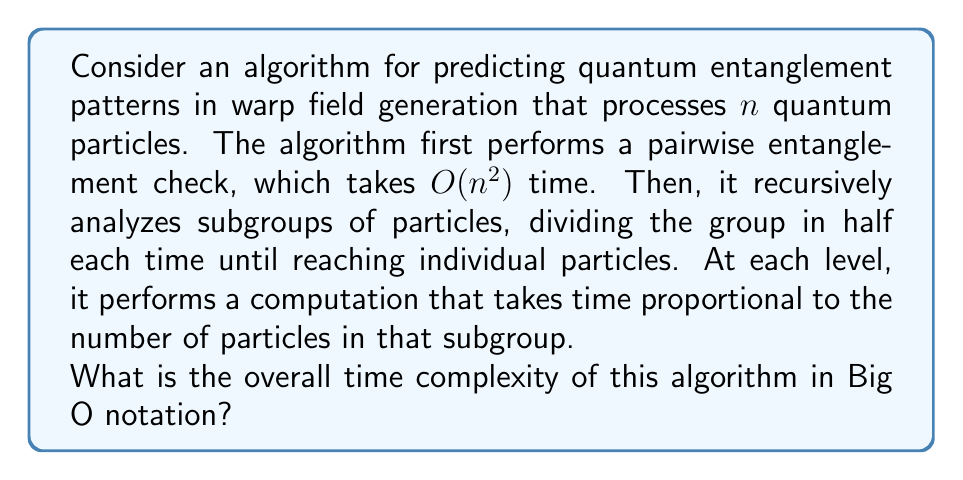Help me with this question. Let's analyze this algorithm step by step:

1) The initial pairwise entanglement check takes $O(n^2)$ time.

2) For the recursive part, let's consider the levels of recursion:
   - Level 0 (top level): 1 group of $n$ particles, $O(n)$ work
   - Level 1: 2 groups of $n/2$ particles each, $O(n/2)$ work per group
   - Level 2: 4 groups of $n/4$ particles each, $O(n/4)$ work per group
   - ...
   - Level $\log_2 n$: $n$ groups of 1 particle each, $O(1)$ work per group

3) At each level, the total work is still $O(n)$:
   - Level 0: $1 \cdot O(n) = O(n)$
   - Level 1: $2 \cdot O(n/2) = O(n)$
   - Level 2: $4 \cdot O(n/4) = O(n)$
   - ...
   - Level $\log_2 n$: $n \cdot O(1) = O(n)$

4) There are $\log_2 n + 1$ levels in total.

5) So, the work for the recursive part is $O(n \log n)$.

6) Combining the initial $O(n^2)$ work with the recursive $O(n \log n)$ work, we get:

   $O(n^2) + O(n \log n)$

7) As $n$ grows, the $n^2$ term dominates, so we can simplify this to $O(n^2)$.

Therefore, the overall time complexity of the algorithm is $O(n^2)$.
Answer: $O(n^2)$ 